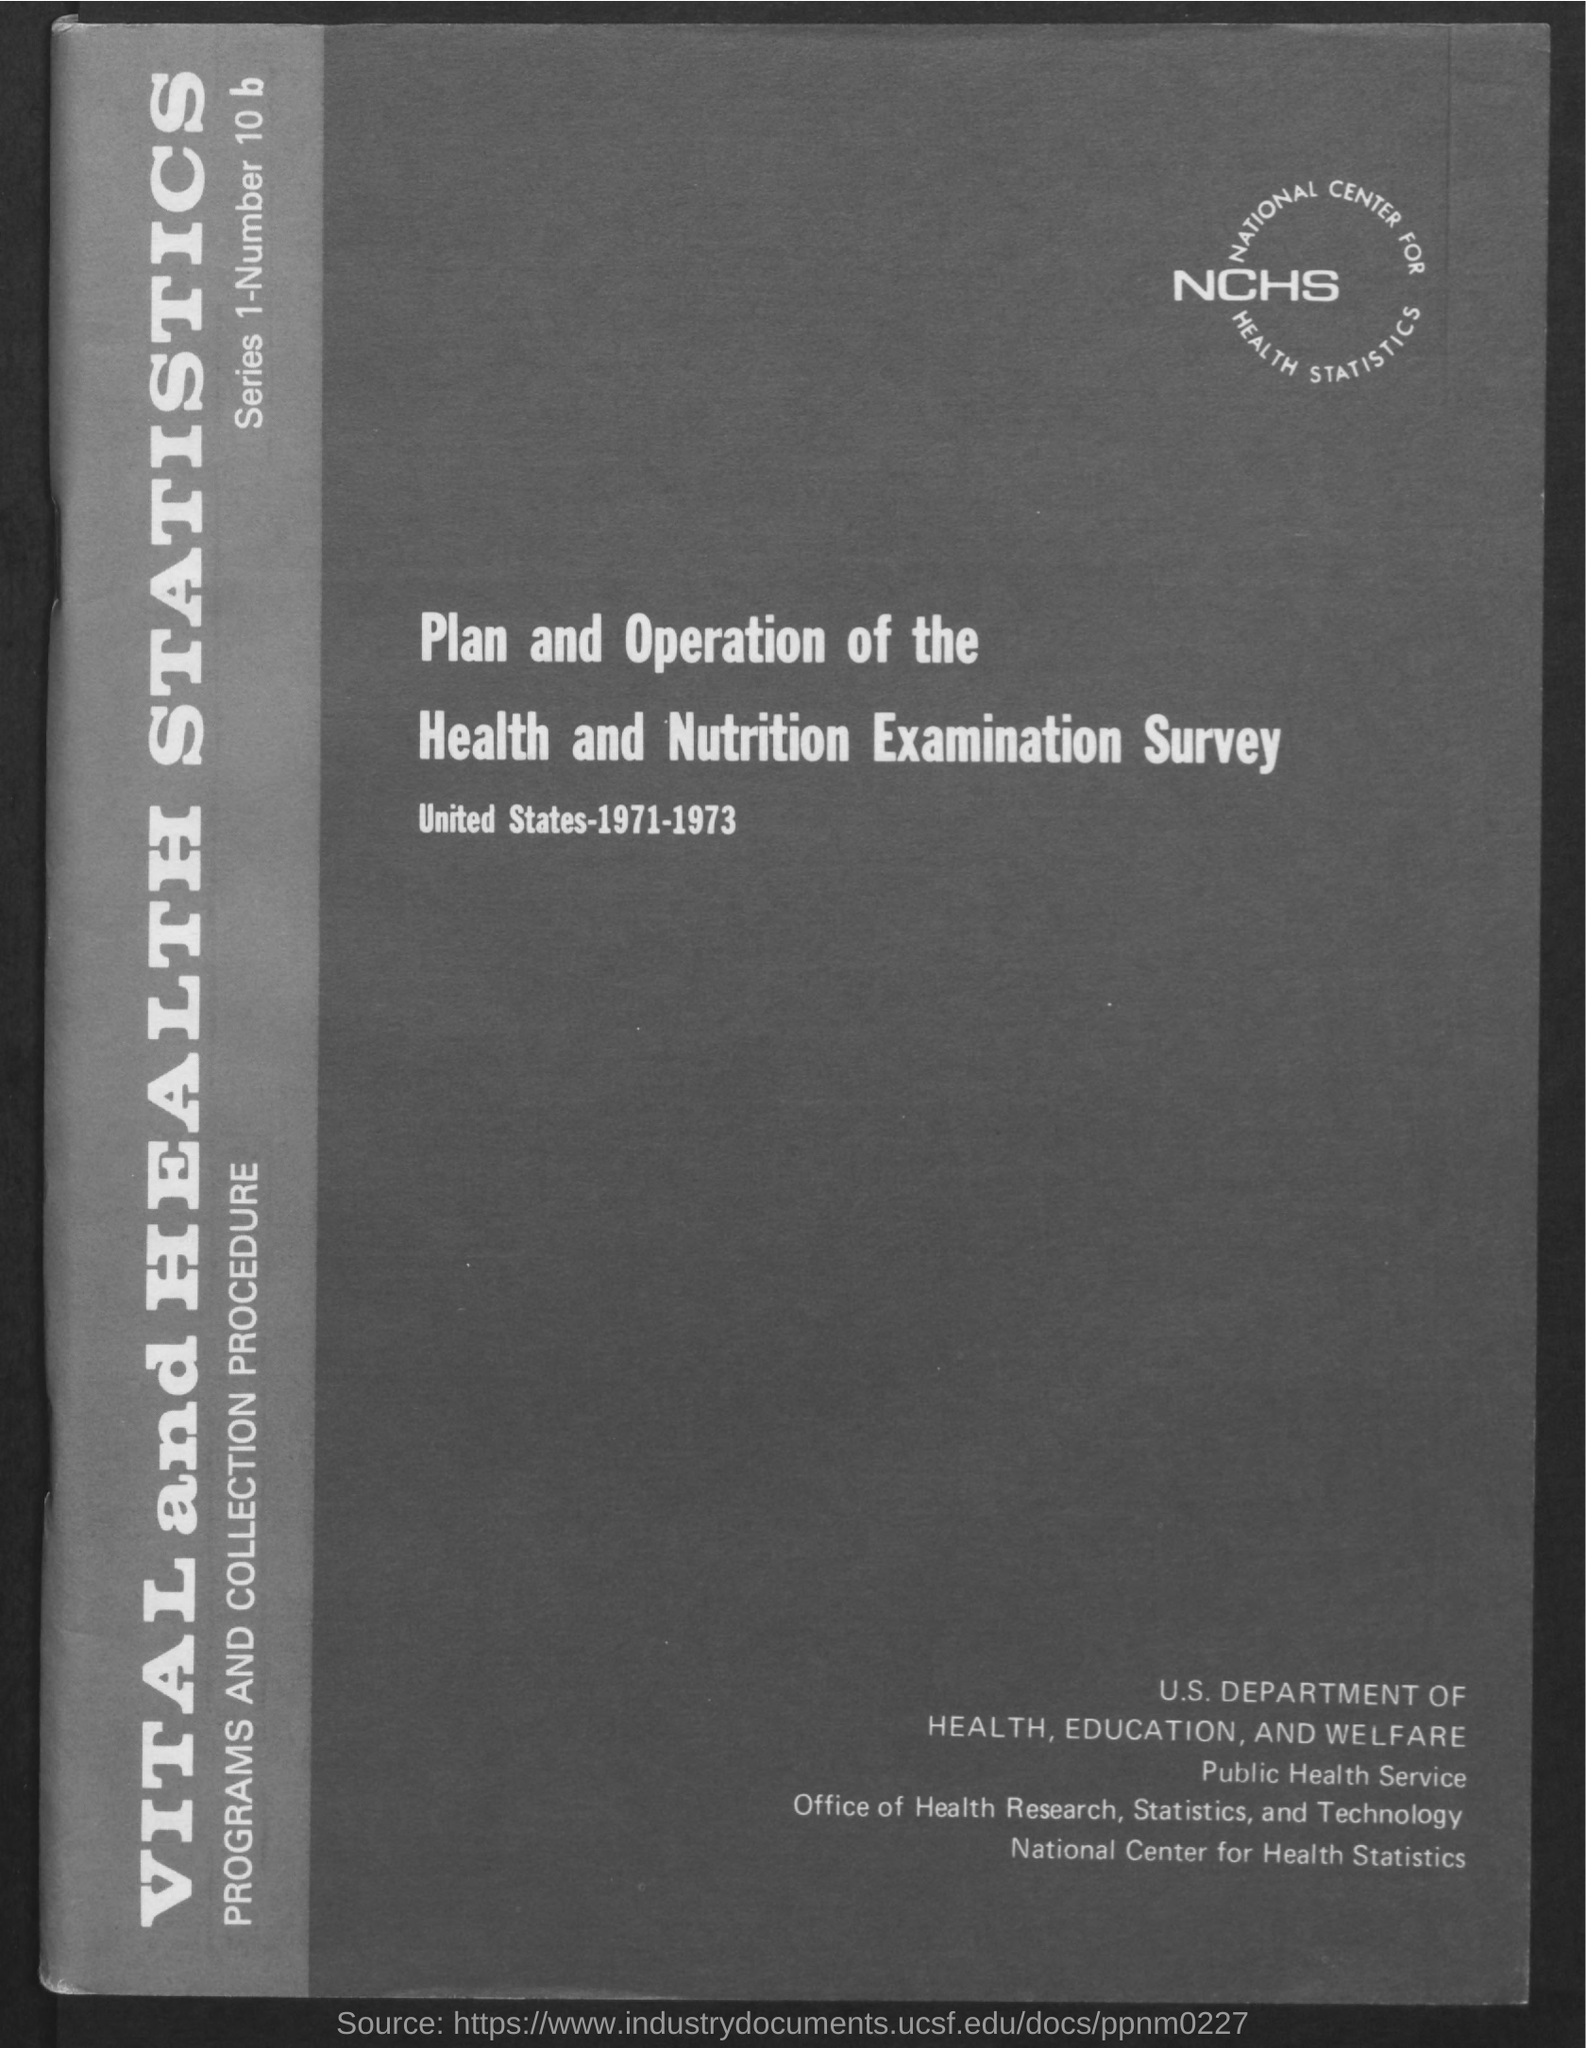Mention a couple of crucial points in this snapshot. The National Center for Health Statistics is an agency of the US Department of Health and Human Services that is responsible for collecting, analyzing, and disseminating information on the health of the American population. It plays a critical role in informing public health policy and promoting the health of all Americans. 